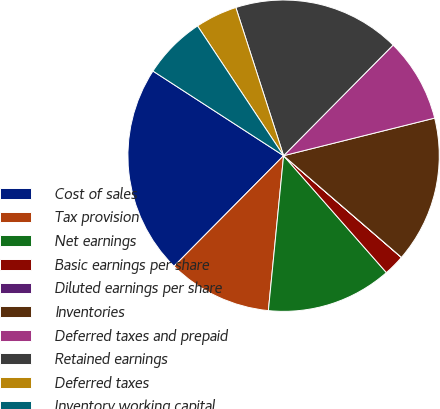Convert chart. <chart><loc_0><loc_0><loc_500><loc_500><pie_chart><fcel>Cost of sales<fcel>Tax provision<fcel>Net earnings<fcel>Basic earnings per share<fcel>Diluted earnings per share<fcel>Inventories<fcel>Deferred taxes and prepaid<fcel>Retained earnings<fcel>Deferred taxes<fcel>Inventory working capital<nl><fcel>21.72%<fcel>10.87%<fcel>13.04%<fcel>2.18%<fcel>0.01%<fcel>15.21%<fcel>8.7%<fcel>17.38%<fcel>4.36%<fcel>6.53%<nl></chart> 